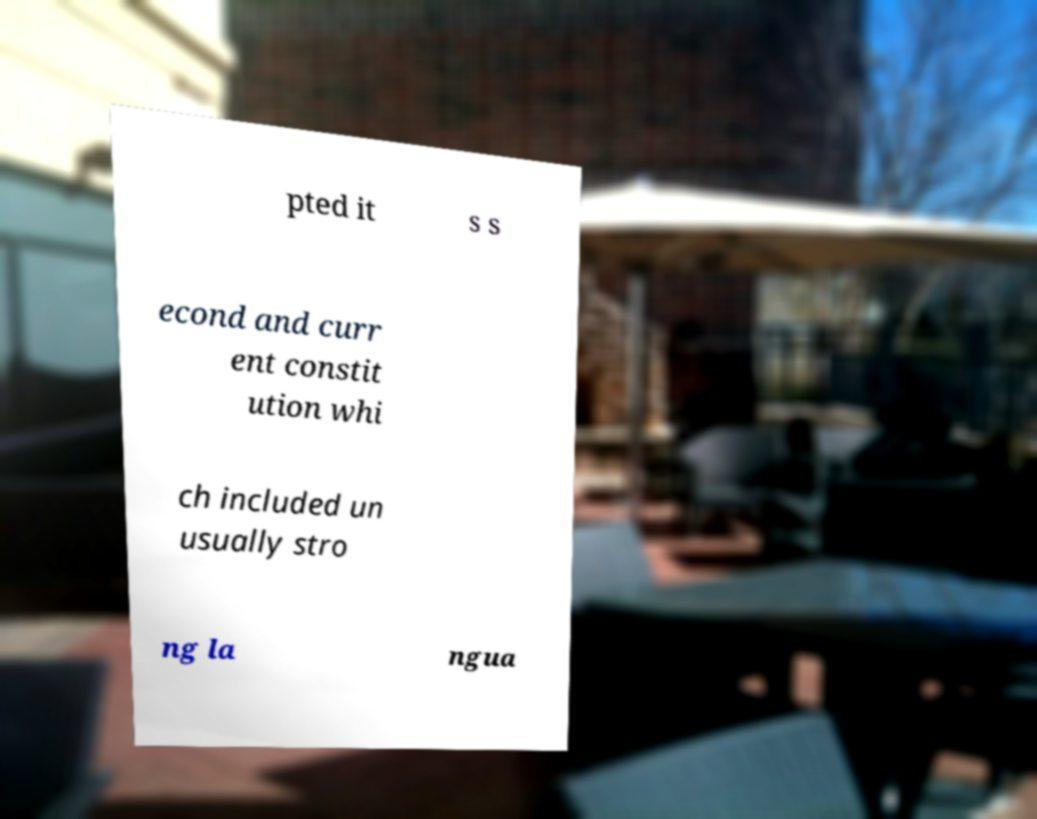Please identify and transcribe the text found in this image. pted it s s econd and curr ent constit ution whi ch included un usually stro ng la ngua 